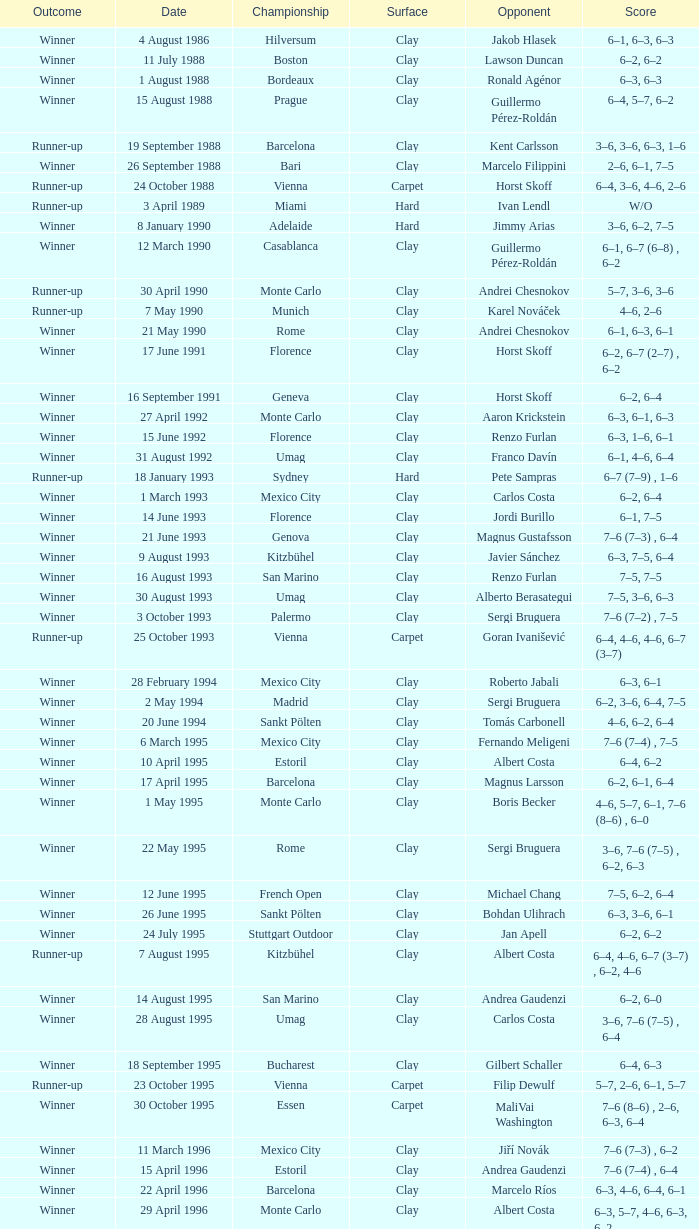What is the surface on 21 june 1993? Clay. 